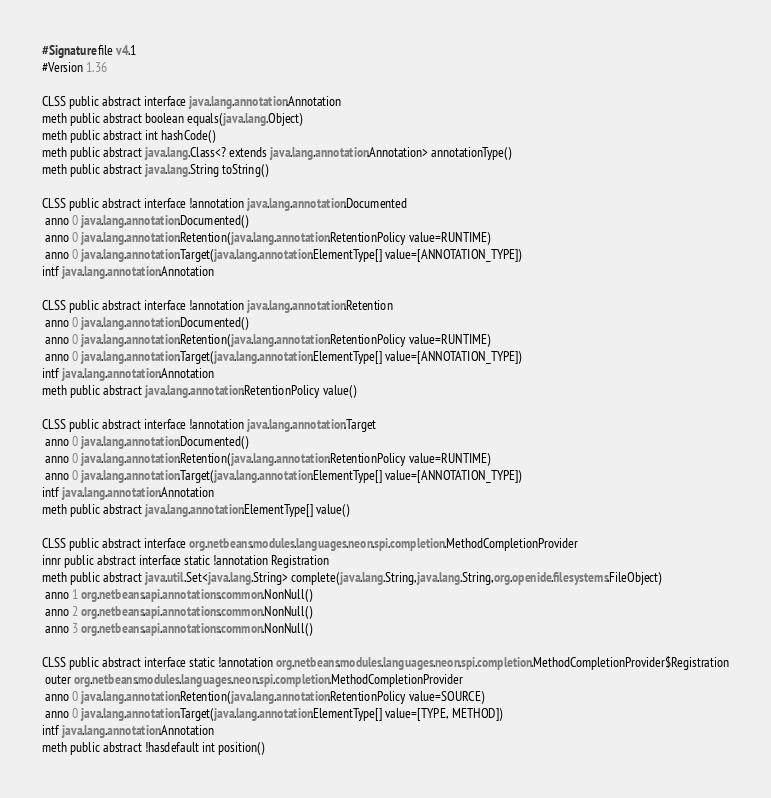<code> <loc_0><loc_0><loc_500><loc_500><_SML_>#Signature file v4.1
#Version 1.36

CLSS public abstract interface java.lang.annotation.Annotation
meth public abstract boolean equals(java.lang.Object)
meth public abstract int hashCode()
meth public abstract java.lang.Class<? extends java.lang.annotation.Annotation> annotationType()
meth public abstract java.lang.String toString()

CLSS public abstract interface !annotation java.lang.annotation.Documented
 anno 0 java.lang.annotation.Documented()
 anno 0 java.lang.annotation.Retention(java.lang.annotation.RetentionPolicy value=RUNTIME)
 anno 0 java.lang.annotation.Target(java.lang.annotation.ElementType[] value=[ANNOTATION_TYPE])
intf java.lang.annotation.Annotation

CLSS public abstract interface !annotation java.lang.annotation.Retention
 anno 0 java.lang.annotation.Documented()
 anno 0 java.lang.annotation.Retention(java.lang.annotation.RetentionPolicy value=RUNTIME)
 anno 0 java.lang.annotation.Target(java.lang.annotation.ElementType[] value=[ANNOTATION_TYPE])
intf java.lang.annotation.Annotation
meth public abstract java.lang.annotation.RetentionPolicy value()

CLSS public abstract interface !annotation java.lang.annotation.Target
 anno 0 java.lang.annotation.Documented()
 anno 0 java.lang.annotation.Retention(java.lang.annotation.RetentionPolicy value=RUNTIME)
 anno 0 java.lang.annotation.Target(java.lang.annotation.ElementType[] value=[ANNOTATION_TYPE])
intf java.lang.annotation.Annotation
meth public abstract java.lang.annotation.ElementType[] value()

CLSS public abstract interface org.netbeans.modules.languages.neon.spi.completion.MethodCompletionProvider
innr public abstract interface static !annotation Registration
meth public abstract java.util.Set<java.lang.String> complete(java.lang.String,java.lang.String,org.openide.filesystems.FileObject)
 anno 1 org.netbeans.api.annotations.common.NonNull()
 anno 2 org.netbeans.api.annotations.common.NonNull()
 anno 3 org.netbeans.api.annotations.common.NonNull()

CLSS public abstract interface static !annotation org.netbeans.modules.languages.neon.spi.completion.MethodCompletionProvider$Registration
 outer org.netbeans.modules.languages.neon.spi.completion.MethodCompletionProvider
 anno 0 java.lang.annotation.Retention(java.lang.annotation.RetentionPolicy value=SOURCE)
 anno 0 java.lang.annotation.Target(java.lang.annotation.ElementType[] value=[TYPE, METHOD])
intf java.lang.annotation.Annotation
meth public abstract !hasdefault int position()

</code> 